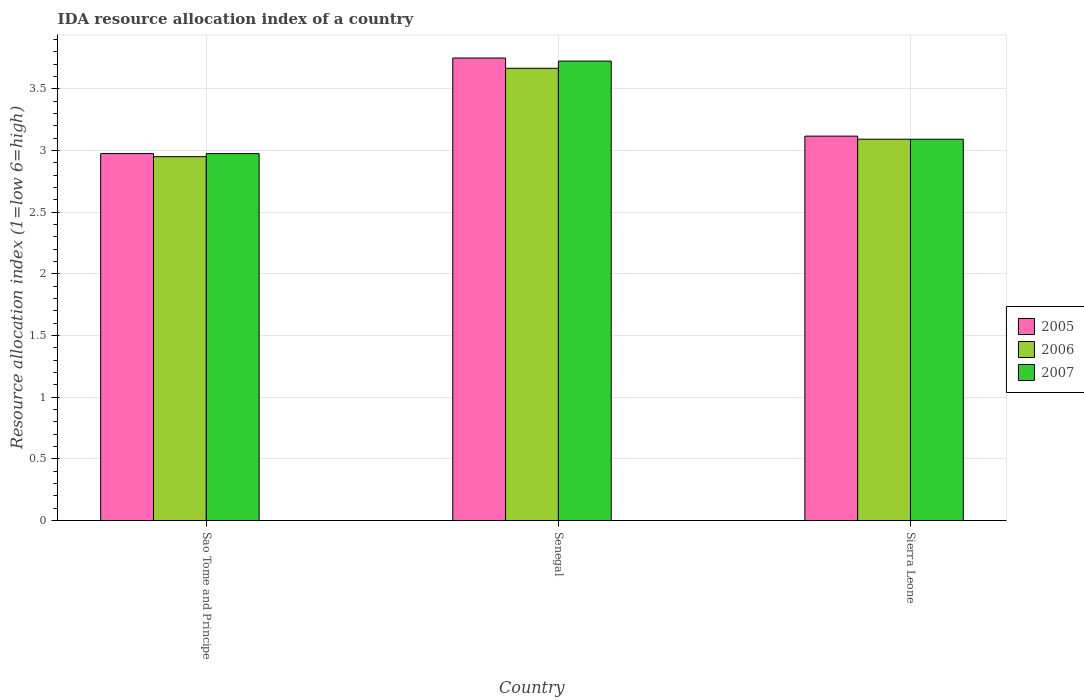How many different coloured bars are there?
Your answer should be compact. 3. How many groups of bars are there?
Provide a short and direct response. 3. How many bars are there on the 2nd tick from the left?
Provide a short and direct response. 3. What is the label of the 1st group of bars from the left?
Offer a terse response. Sao Tome and Principe. What is the IDA resource allocation index in 2005 in Sierra Leone?
Your response must be concise. 3.12. Across all countries, what is the maximum IDA resource allocation index in 2007?
Your answer should be very brief. 3.73. Across all countries, what is the minimum IDA resource allocation index in 2006?
Offer a very short reply. 2.95. In which country was the IDA resource allocation index in 2007 maximum?
Make the answer very short. Senegal. In which country was the IDA resource allocation index in 2005 minimum?
Ensure brevity in your answer.  Sao Tome and Principe. What is the total IDA resource allocation index in 2005 in the graph?
Keep it short and to the point. 9.84. What is the difference between the IDA resource allocation index in 2007 in Sao Tome and Principe and that in Senegal?
Offer a very short reply. -0.75. What is the difference between the IDA resource allocation index in 2005 in Senegal and the IDA resource allocation index in 2007 in Sierra Leone?
Provide a short and direct response. 0.66. What is the average IDA resource allocation index in 2005 per country?
Your response must be concise. 3.28. What is the difference between the IDA resource allocation index of/in 2006 and IDA resource allocation index of/in 2007 in Senegal?
Keep it short and to the point. -0.06. In how many countries, is the IDA resource allocation index in 2007 greater than 0.9?
Ensure brevity in your answer.  3. What is the ratio of the IDA resource allocation index in 2005 in Senegal to that in Sierra Leone?
Provide a succinct answer. 1.2. Is the IDA resource allocation index in 2007 in Sao Tome and Principe less than that in Senegal?
Offer a very short reply. Yes. Is the difference between the IDA resource allocation index in 2006 in Senegal and Sierra Leone greater than the difference between the IDA resource allocation index in 2007 in Senegal and Sierra Leone?
Offer a terse response. No. What is the difference between the highest and the second highest IDA resource allocation index in 2007?
Provide a short and direct response. 0.12. What is the difference between the highest and the lowest IDA resource allocation index in 2007?
Give a very brief answer. 0.75. In how many countries, is the IDA resource allocation index in 2005 greater than the average IDA resource allocation index in 2005 taken over all countries?
Keep it short and to the point. 1. What does the 2nd bar from the right in Senegal represents?
Provide a succinct answer. 2006. Is it the case that in every country, the sum of the IDA resource allocation index in 2006 and IDA resource allocation index in 2007 is greater than the IDA resource allocation index in 2005?
Give a very brief answer. Yes. How many bars are there?
Offer a very short reply. 9. How many countries are there in the graph?
Your response must be concise. 3. What is the difference between two consecutive major ticks on the Y-axis?
Ensure brevity in your answer.  0.5. Does the graph contain any zero values?
Make the answer very short. No. Where does the legend appear in the graph?
Keep it short and to the point. Center right. How many legend labels are there?
Provide a short and direct response. 3. How are the legend labels stacked?
Provide a short and direct response. Vertical. What is the title of the graph?
Offer a very short reply. IDA resource allocation index of a country. What is the label or title of the Y-axis?
Your answer should be very brief. Resource allocation index (1=low 6=high). What is the Resource allocation index (1=low 6=high) in 2005 in Sao Tome and Principe?
Make the answer very short. 2.98. What is the Resource allocation index (1=low 6=high) in 2006 in Sao Tome and Principe?
Make the answer very short. 2.95. What is the Resource allocation index (1=low 6=high) of 2007 in Sao Tome and Principe?
Give a very brief answer. 2.98. What is the Resource allocation index (1=low 6=high) in 2005 in Senegal?
Provide a short and direct response. 3.75. What is the Resource allocation index (1=low 6=high) of 2006 in Senegal?
Ensure brevity in your answer.  3.67. What is the Resource allocation index (1=low 6=high) of 2007 in Senegal?
Ensure brevity in your answer.  3.73. What is the Resource allocation index (1=low 6=high) in 2005 in Sierra Leone?
Ensure brevity in your answer.  3.12. What is the Resource allocation index (1=low 6=high) of 2006 in Sierra Leone?
Ensure brevity in your answer.  3.09. What is the Resource allocation index (1=low 6=high) in 2007 in Sierra Leone?
Make the answer very short. 3.09. Across all countries, what is the maximum Resource allocation index (1=low 6=high) of 2005?
Ensure brevity in your answer.  3.75. Across all countries, what is the maximum Resource allocation index (1=low 6=high) in 2006?
Provide a short and direct response. 3.67. Across all countries, what is the maximum Resource allocation index (1=low 6=high) in 2007?
Make the answer very short. 3.73. Across all countries, what is the minimum Resource allocation index (1=low 6=high) in 2005?
Provide a short and direct response. 2.98. Across all countries, what is the minimum Resource allocation index (1=low 6=high) in 2006?
Provide a succinct answer. 2.95. Across all countries, what is the minimum Resource allocation index (1=low 6=high) in 2007?
Your answer should be compact. 2.98. What is the total Resource allocation index (1=low 6=high) of 2005 in the graph?
Provide a succinct answer. 9.84. What is the total Resource allocation index (1=low 6=high) in 2006 in the graph?
Your answer should be very brief. 9.71. What is the total Resource allocation index (1=low 6=high) in 2007 in the graph?
Your answer should be compact. 9.79. What is the difference between the Resource allocation index (1=low 6=high) of 2005 in Sao Tome and Principe and that in Senegal?
Offer a terse response. -0.78. What is the difference between the Resource allocation index (1=low 6=high) in 2006 in Sao Tome and Principe and that in Senegal?
Your answer should be compact. -0.72. What is the difference between the Resource allocation index (1=low 6=high) of 2007 in Sao Tome and Principe and that in Senegal?
Offer a very short reply. -0.75. What is the difference between the Resource allocation index (1=low 6=high) in 2005 in Sao Tome and Principe and that in Sierra Leone?
Offer a very short reply. -0.14. What is the difference between the Resource allocation index (1=low 6=high) of 2006 in Sao Tome and Principe and that in Sierra Leone?
Provide a succinct answer. -0.14. What is the difference between the Resource allocation index (1=low 6=high) of 2007 in Sao Tome and Principe and that in Sierra Leone?
Your response must be concise. -0.12. What is the difference between the Resource allocation index (1=low 6=high) of 2005 in Senegal and that in Sierra Leone?
Your answer should be compact. 0.63. What is the difference between the Resource allocation index (1=low 6=high) in 2006 in Senegal and that in Sierra Leone?
Offer a terse response. 0.57. What is the difference between the Resource allocation index (1=low 6=high) of 2007 in Senegal and that in Sierra Leone?
Offer a very short reply. 0.63. What is the difference between the Resource allocation index (1=low 6=high) in 2005 in Sao Tome and Principe and the Resource allocation index (1=low 6=high) in 2006 in Senegal?
Your answer should be compact. -0.69. What is the difference between the Resource allocation index (1=low 6=high) of 2005 in Sao Tome and Principe and the Resource allocation index (1=low 6=high) of 2007 in Senegal?
Your response must be concise. -0.75. What is the difference between the Resource allocation index (1=low 6=high) in 2006 in Sao Tome and Principe and the Resource allocation index (1=low 6=high) in 2007 in Senegal?
Offer a very short reply. -0.78. What is the difference between the Resource allocation index (1=low 6=high) in 2005 in Sao Tome and Principe and the Resource allocation index (1=low 6=high) in 2006 in Sierra Leone?
Your response must be concise. -0.12. What is the difference between the Resource allocation index (1=low 6=high) in 2005 in Sao Tome and Principe and the Resource allocation index (1=low 6=high) in 2007 in Sierra Leone?
Offer a terse response. -0.12. What is the difference between the Resource allocation index (1=low 6=high) of 2006 in Sao Tome and Principe and the Resource allocation index (1=low 6=high) of 2007 in Sierra Leone?
Your answer should be very brief. -0.14. What is the difference between the Resource allocation index (1=low 6=high) of 2005 in Senegal and the Resource allocation index (1=low 6=high) of 2006 in Sierra Leone?
Offer a very short reply. 0.66. What is the difference between the Resource allocation index (1=low 6=high) in 2005 in Senegal and the Resource allocation index (1=low 6=high) in 2007 in Sierra Leone?
Provide a short and direct response. 0.66. What is the difference between the Resource allocation index (1=low 6=high) in 2006 in Senegal and the Resource allocation index (1=low 6=high) in 2007 in Sierra Leone?
Make the answer very short. 0.57. What is the average Resource allocation index (1=low 6=high) of 2005 per country?
Your answer should be very brief. 3.28. What is the average Resource allocation index (1=low 6=high) in 2006 per country?
Offer a terse response. 3.24. What is the average Resource allocation index (1=low 6=high) of 2007 per country?
Keep it short and to the point. 3.26. What is the difference between the Resource allocation index (1=low 6=high) in 2005 and Resource allocation index (1=low 6=high) in 2006 in Sao Tome and Principe?
Keep it short and to the point. 0.03. What is the difference between the Resource allocation index (1=low 6=high) of 2006 and Resource allocation index (1=low 6=high) of 2007 in Sao Tome and Principe?
Ensure brevity in your answer.  -0.03. What is the difference between the Resource allocation index (1=low 6=high) of 2005 and Resource allocation index (1=low 6=high) of 2006 in Senegal?
Offer a very short reply. 0.08. What is the difference between the Resource allocation index (1=low 6=high) in 2005 and Resource allocation index (1=low 6=high) in 2007 in Senegal?
Your answer should be very brief. 0.03. What is the difference between the Resource allocation index (1=low 6=high) in 2006 and Resource allocation index (1=low 6=high) in 2007 in Senegal?
Offer a very short reply. -0.06. What is the difference between the Resource allocation index (1=low 6=high) in 2005 and Resource allocation index (1=low 6=high) in 2006 in Sierra Leone?
Your answer should be very brief. 0.03. What is the difference between the Resource allocation index (1=low 6=high) of 2005 and Resource allocation index (1=low 6=high) of 2007 in Sierra Leone?
Keep it short and to the point. 0.03. What is the difference between the Resource allocation index (1=low 6=high) of 2006 and Resource allocation index (1=low 6=high) of 2007 in Sierra Leone?
Offer a terse response. 0. What is the ratio of the Resource allocation index (1=low 6=high) in 2005 in Sao Tome and Principe to that in Senegal?
Provide a succinct answer. 0.79. What is the ratio of the Resource allocation index (1=low 6=high) in 2006 in Sao Tome and Principe to that in Senegal?
Offer a very short reply. 0.8. What is the ratio of the Resource allocation index (1=low 6=high) in 2007 in Sao Tome and Principe to that in Senegal?
Provide a short and direct response. 0.8. What is the ratio of the Resource allocation index (1=low 6=high) of 2005 in Sao Tome and Principe to that in Sierra Leone?
Your answer should be compact. 0.95. What is the ratio of the Resource allocation index (1=low 6=high) of 2006 in Sao Tome and Principe to that in Sierra Leone?
Make the answer very short. 0.95. What is the ratio of the Resource allocation index (1=low 6=high) of 2007 in Sao Tome and Principe to that in Sierra Leone?
Offer a very short reply. 0.96. What is the ratio of the Resource allocation index (1=low 6=high) in 2005 in Senegal to that in Sierra Leone?
Keep it short and to the point. 1.2. What is the ratio of the Resource allocation index (1=low 6=high) of 2006 in Senegal to that in Sierra Leone?
Your answer should be very brief. 1.19. What is the ratio of the Resource allocation index (1=low 6=high) in 2007 in Senegal to that in Sierra Leone?
Offer a terse response. 1.2. What is the difference between the highest and the second highest Resource allocation index (1=low 6=high) of 2005?
Your response must be concise. 0.63. What is the difference between the highest and the second highest Resource allocation index (1=low 6=high) of 2006?
Give a very brief answer. 0.57. What is the difference between the highest and the second highest Resource allocation index (1=low 6=high) in 2007?
Give a very brief answer. 0.63. What is the difference between the highest and the lowest Resource allocation index (1=low 6=high) in 2005?
Provide a short and direct response. 0.78. What is the difference between the highest and the lowest Resource allocation index (1=low 6=high) of 2006?
Offer a terse response. 0.72. What is the difference between the highest and the lowest Resource allocation index (1=low 6=high) in 2007?
Ensure brevity in your answer.  0.75. 